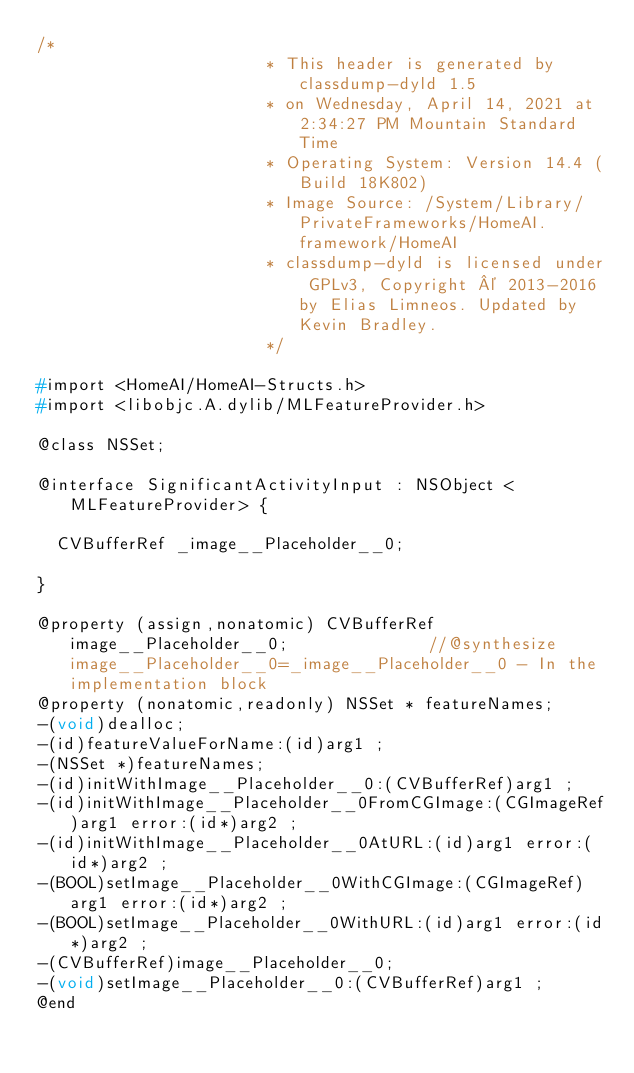<code> <loc_0><loc_0><loc_500><loc_500><_C_>/*
                       * This header is generated by classdump-dyld 1.5
                       * on Wednesday, April 14, 2021 at 2:34:27 PM Mountain Standard Time
                       * Operating System: Version 14.4 (Build 18K802)
                       * Image Source: /System/Library/PrivateFrameworks/HomeAI.framework/HomeAI
                       * classdump-dyld is licensed under GPLv3, Copyright © 2013-2016 by Elias Limneos. Updated by Kevin Bradley.
                       */

#import <HomeAI/HomeAI-Structs.h>
#import <libobjc.A.dylib/MLFeatureProvider.h>

@class NSSet;

@interface SignificantActivityInput : NSObject <MLFeatureProvider> {

	CVBufferRef _image__Placeholder__0;

}

@property (assign,nonatomic) CVBufferRef image__Placeholder__0;              //@synthesize image__Placeholder__0=_image__Placeholder__0 - In the implementation block
@property (nonatomic,readonly) NSSet * featureNames; 
-(void)dealloc;
-(id)featureValueForName:(id)arg1 ;
-(NSSet *)featureNames;
-(id)initWithImage__Placeholder__0:(CVBufferRef)arg1 ;
-(id)initWithImage__Placeholder__0FromCGImage:(CGImageRef)arg1 error:(id*)arg2 ;
-(id)initWithImage__Placeholder__0AtURL:(id)arg1 error:(id*)arg2 ;
-(BOOL)setImage__Placeholder__0WithCGImage:(CGImageRef)arg1 error:(id*)arg2 ;
-(BOOL)setImage__Placeholder__0WithURL:(id)arg1 error:(id*)arg2 ;
-(CVBufferRef)image__Placeholder__0;
-(void)setImage__Placeholder__0:(CVBufferRef)arg1 ;
@end

</code> 